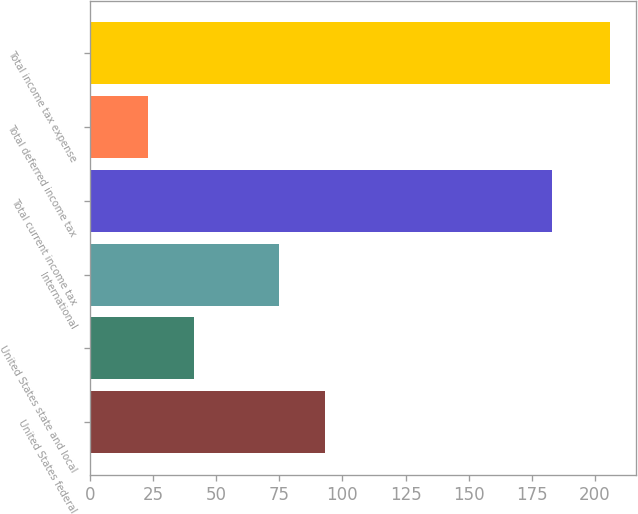Convert chart to OTSL. <chart><loc_0><loc_0><loc_500><loc_500><bar_chart><fcel>United States federal<fcel>United States state and local<fcel>International<fcel>Total current income tax<fcel>Total deferred income tax<fcel>Total income tax expense<nl><fcel>93.3<fcel>41.3<fcel>75<fcel>183<fcel>23<fcel>206<nl></chart> 